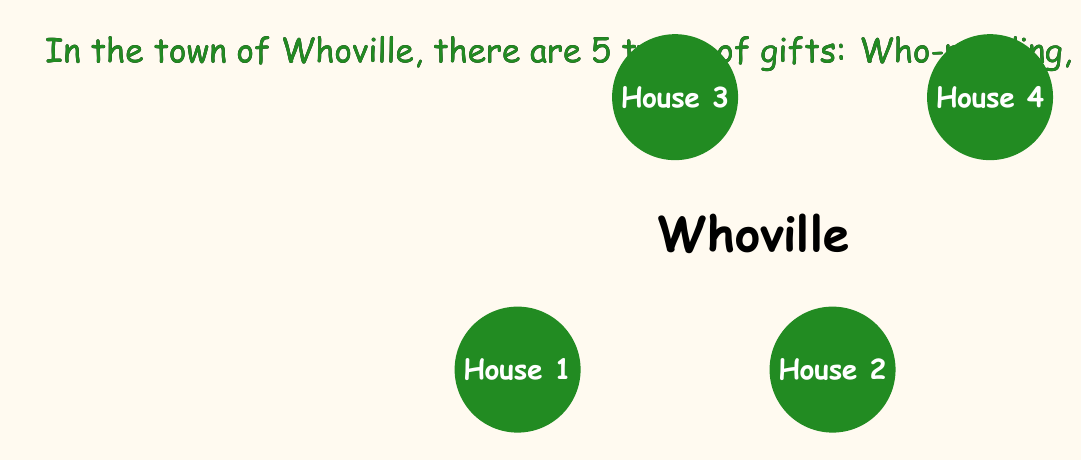Provide a solution to this math problem. Let's approach this problem step-by-step:

1) First, we need to calculate the number of ways to choose gifts from a single house. For each type of gift, the Grinch has two options: take it or not. This gives us $2^5 = 32$ possibilities for each house.

2) However, the Grinch must take at least one gift from each house. So we need to subtract the case where he takes no gifts. This leaves us with $32 - 1 = 31$ valid combinations per house.

3) Now, we need to consider all four houses. Since the choices for each house are independent, we multiply the number of possibilities:

   $$ 31 \times 31 \times 31 \times 31 = 31^4 $$

4) To calculate this:
   $$ 31^4 = (31 \times 31) \times (31 \times 31) = 961 \times 961 = 923,521 $$

Therefore, the Grinch can steal gifts in 923,521 different combinations.

This problem is an application of the multiplication principle in combinatorics, with a twist of the inclusion-exclusion principle to handle the "at least one gift" condition.
Answer: 923,521 